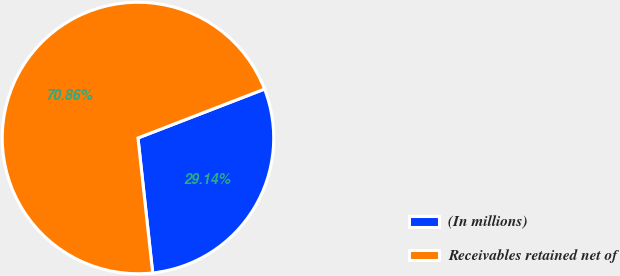Convert chart to OTSL. <chart><loc_0><loc_0><loc_500><loc_500><pie_chart><fcel>(In millions)<fcel>Receivables retained net of<nl><fcel>29.14%<fcel>70.86%<nl></chart> 